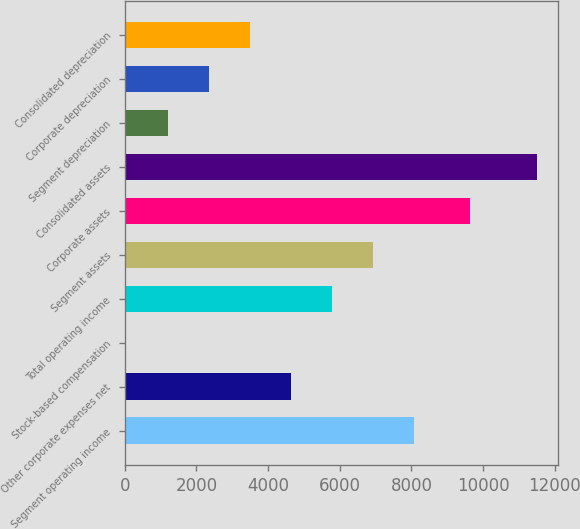Convert chart. <chart><loc_0><loc_0><loc_500><loc_500><bar_chart><fcel>Segment operating income<fcel>Other corporate expenses net<fcel>Stock-based compensation<fcel>Total operating income<fcel>Segment assets<fcel>Corporate assets<fcel>Consolidated assets<fcel>Segment depreciation<fcel>Corporate depreciation<fcel>Consolidated depreciation<nl><fcel>8075.9<fcel>4635.8<fcel>49<fcel>5782.5<fcel>6929.2<fcel>9635<fcel>11516<fcel>1195.7<fcel>2342.4<fcel>3489.1<nl></chart> 